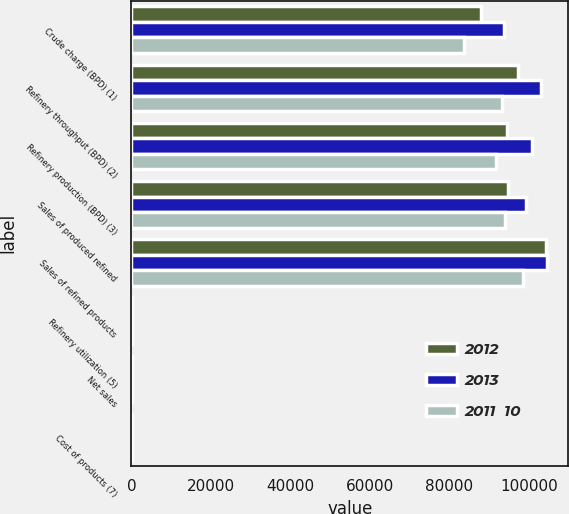Convert chart to OTSL. <chart><loc_0><loc_0><loc_500><loc_500><stacked_bar_chart><ecel><fcel>Crude charge (BPD) (1)<fcel>Refinery throughput (BPD) (2)<fcel>Refinery production (BPD) (3)<fcel>Sales of produced refined<fcel>Sales of refined products<fcel>Refinery utilization (5)<fcel>Net sales<fcel>Cost of products (7)<nl><fcel>2012<fcel>87910<fcel>97310<fcel>94490<fcel>94830<fcel>104320<fcel>87.9<fcel>117.79<fcel>103.88<nl><fcel>2013<fcel>93830<fcel>103120<fcel>100810<fcel>99160<fcel>104620<fcel>93.8<fcel>122.62<fcel>95.7<nl><fcel>2011  10<fcel>83700<fcel>93260<fcel>91810<fcel>93950<fcel>98540<fcel>83.7<fcel>118.76<fcel>98.4<nl></chart> 